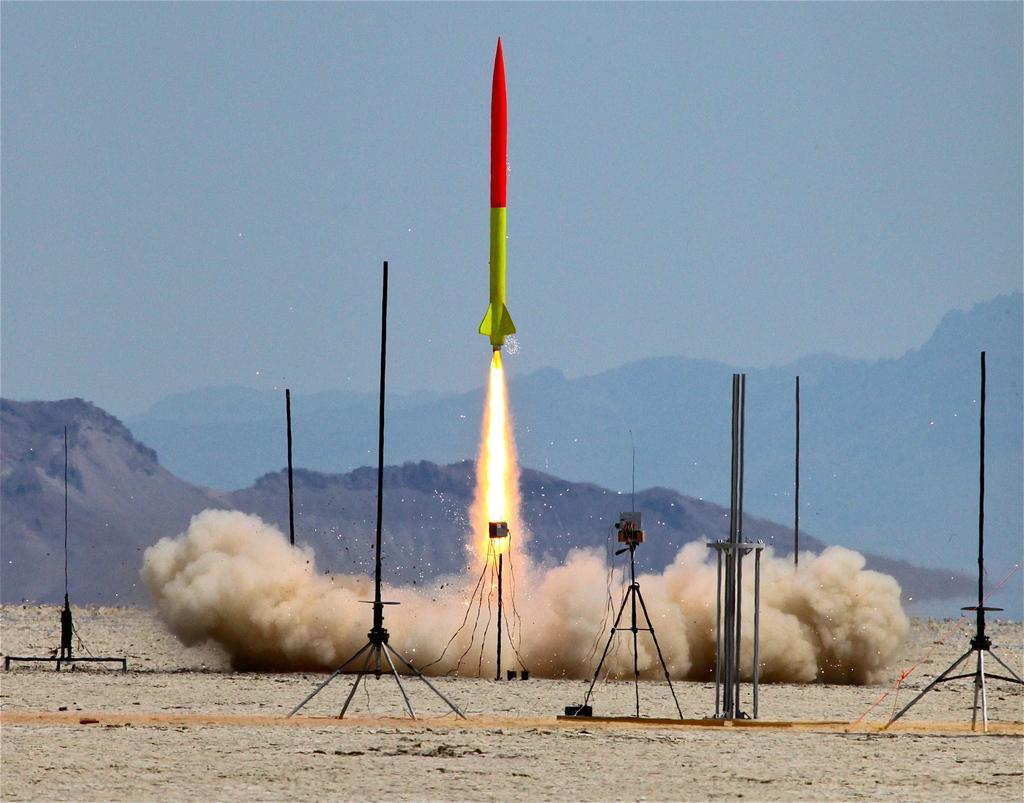What is the main subject of the image? The main subject of the image is a missile. What is happening to the missile in the image? The missile is emitting fire in the image. What type of structures are present in the image? There are metal stands in the image. What type of landscape can be seen in the image? Hills are visible in the image. What is the weather like in the image? The sky is cloudy in the image. Can you see any caves in the image? There are no caves visible in the image. How does the missile help the knee in the image? The image does not depict any knees or any interaction between the missile and a knee. 